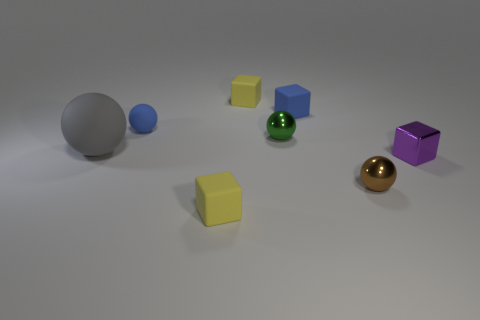Is the color of the big thing that is behind the metal block the same as the small shiny object that is behind the gray rubber object? No, the colors are distinct. The large object behind the metal block exhibits a matte purple hue, while the small shiny object located behind the gray rubber sphere is of a gold color, characterized by its reflective metallic sheen. 